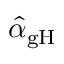<formula> <loc_0><loc_0><loc_500><loc_500>\hat { \alpha } _ { g H }</formula> 